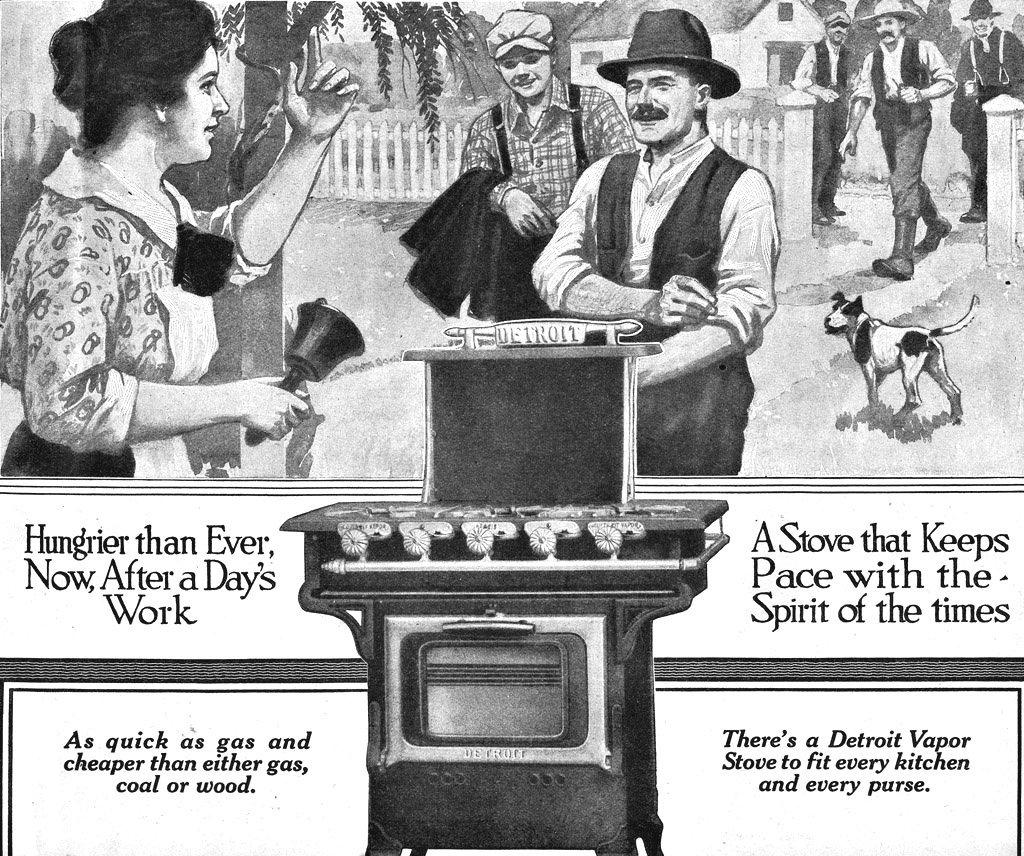<image>
Describe the image concisely. An old advertisement for a Detroit vapor stove. 